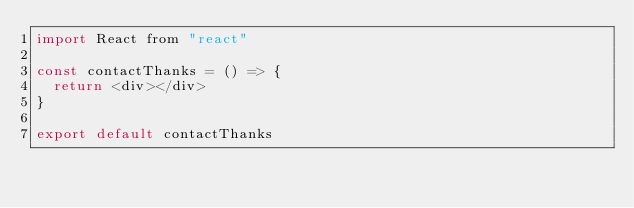Convert code to text. <code><loc_0><loc_0><loc_500><loc_500><_JavaScript_>import React from "react"

const contactThanks = () => {
  return <div></div>
}

export default contactThanks
</code> 